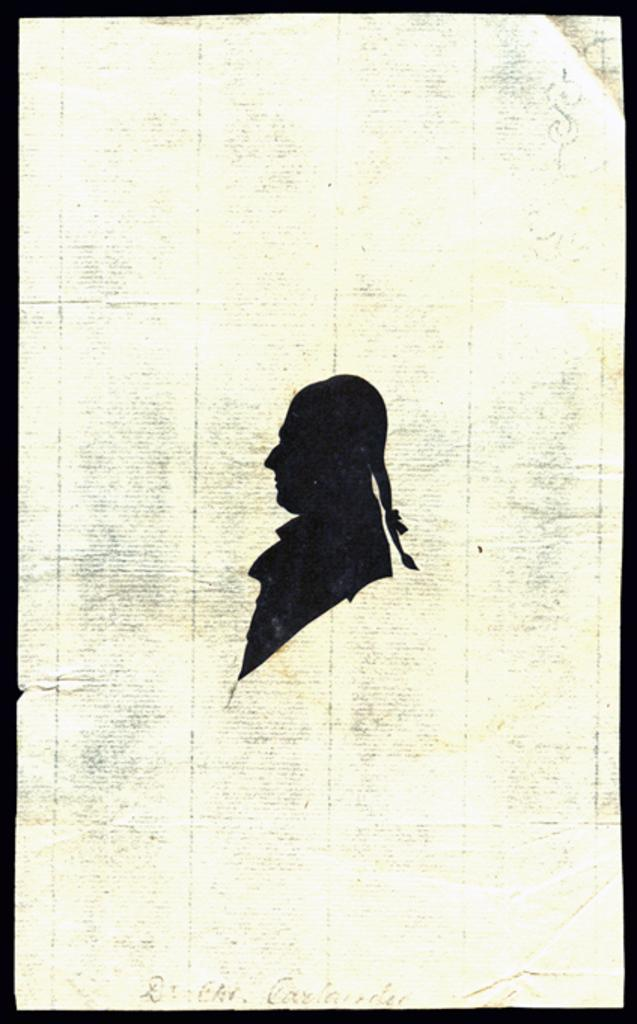What is depicted on the paper in the image? There is a print of a person on the paper. What else can be seen on the paper besides the person? There are words on the paper. What color are the borders of the picture? The borders of the picture are black in color. How does the quilt protect the person from the rainstorm in the image? There is no quilt or rainstorm present in the image; it features a print of a person on a paper with black borders. What type of vest is the person wearing in the image? There is no person wearing a vest in the image; it only shows a print of a person on a paper. 